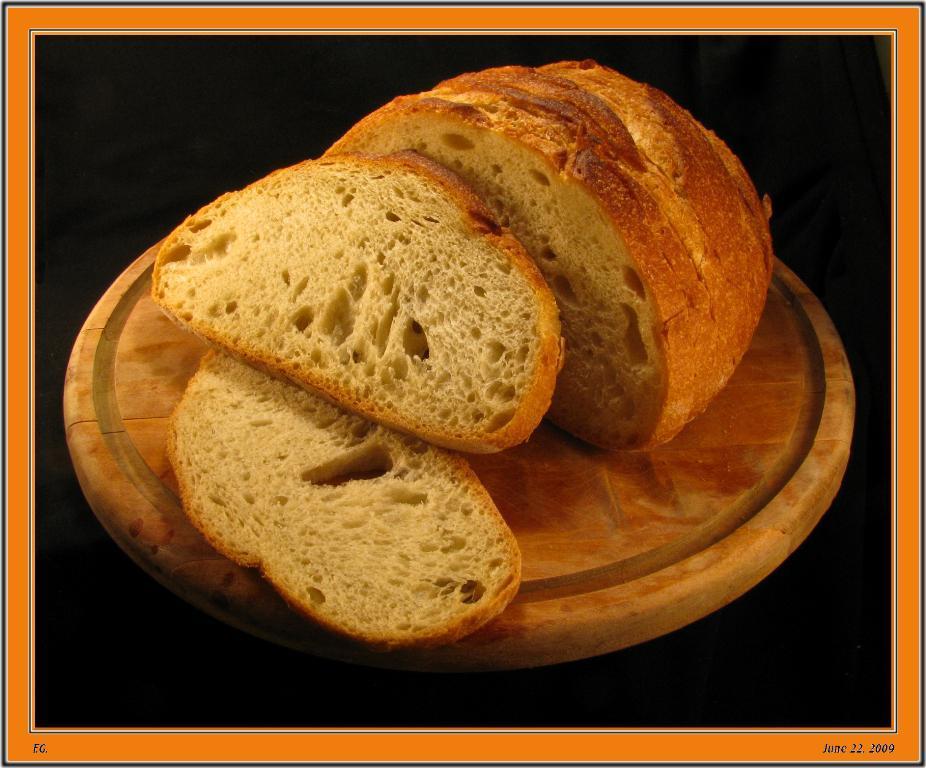How would you summarize this image in a sentence or two? In this image there are slices of bread placed on the wooden board. 